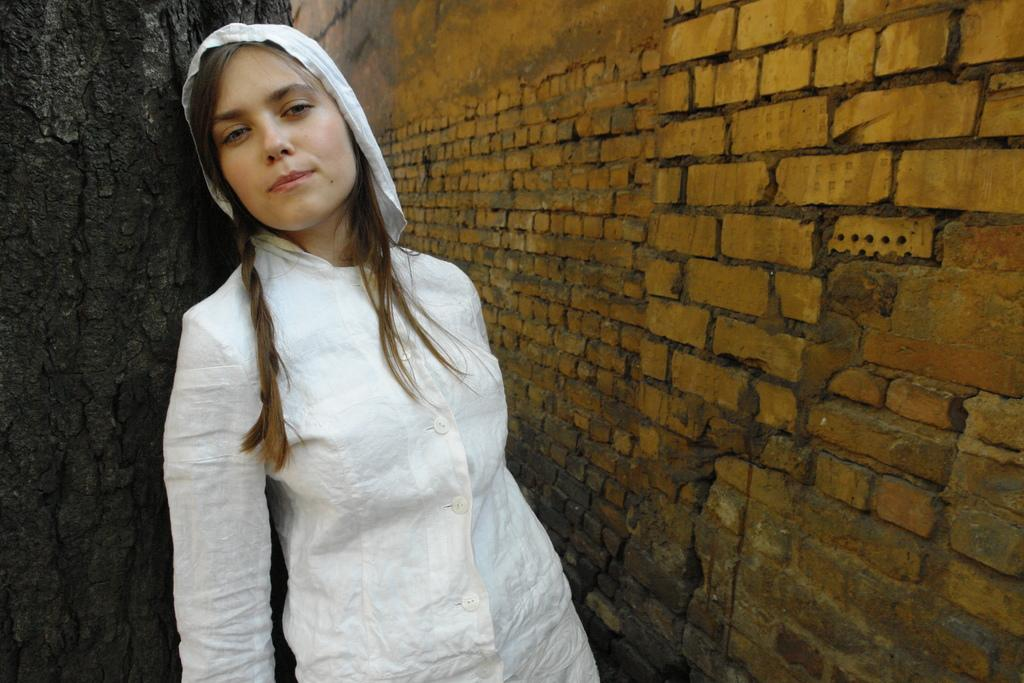Who is the main subject in the image? There is a lady in the image. What can be seen on the right side of the image? There is a brick wall on the right side of the image. What is the lady doing in the image? The lady is leaning on a wood. What type of sugar is visible on the lady's jeans in the image? There is no sugar or jeans present in the image. 